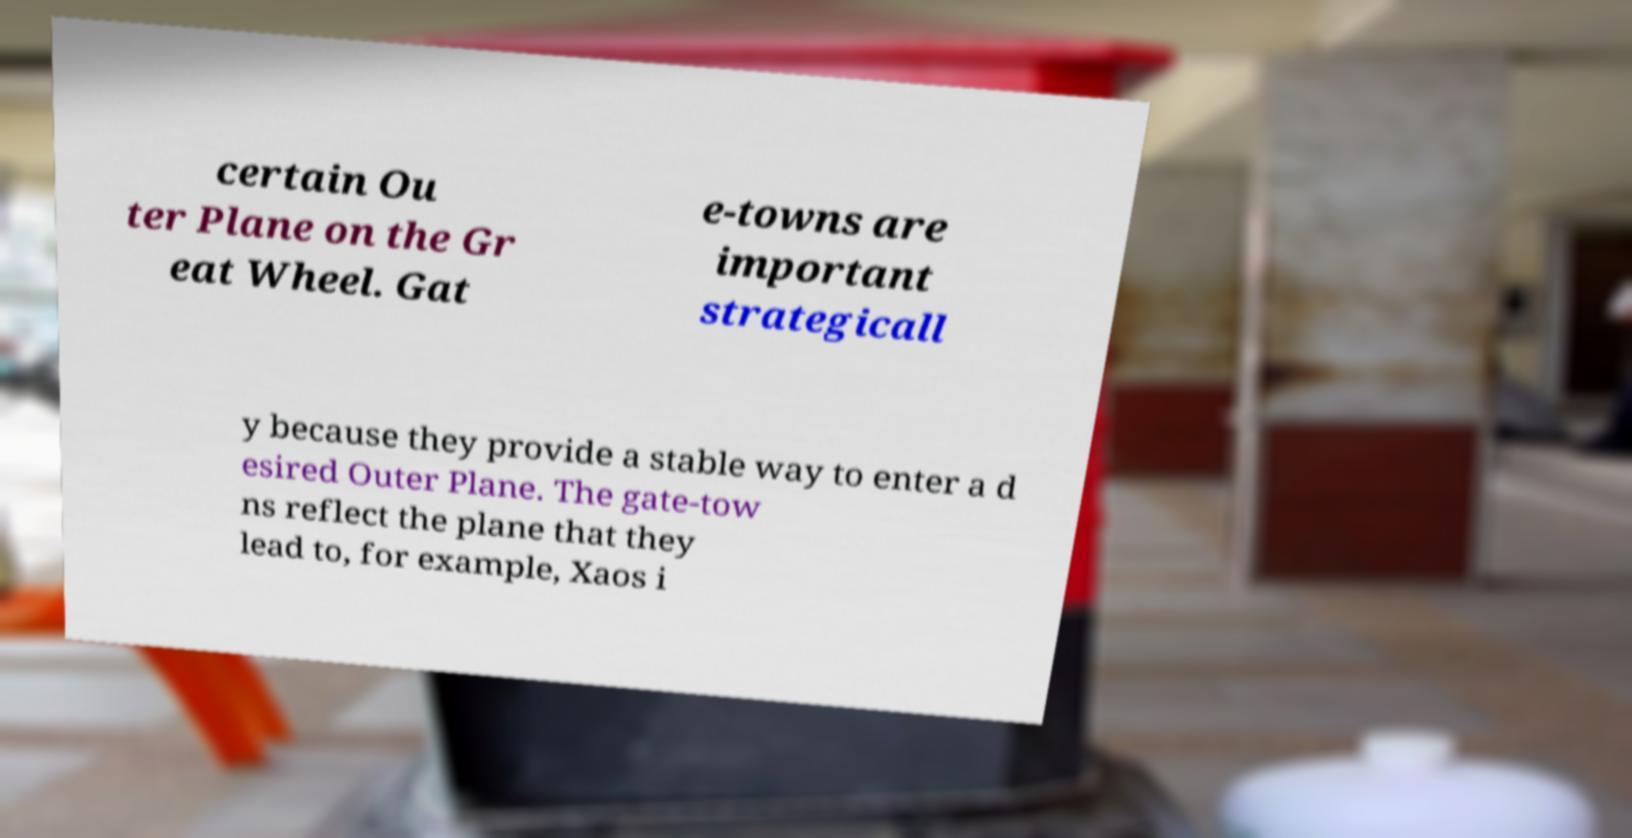Please read and relay the text visible in this image. What does it say? certain Ou ter Plane on the Gr eat Wheel. Gat e-towns are important strategicall y because they provide a stable way to enter a d esired Outer Plane. The gate-tow ns reflect the plane that they lead to, for example, Xaos i 